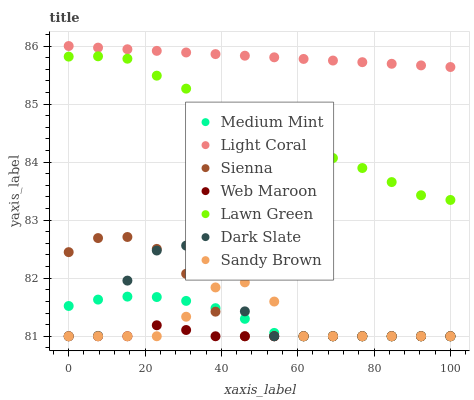Does Web Maroon have the minimum area under the curve?
Answer yes or no. Yes. Does Light Coral have the maximum area under the curve?
Answer yes or no. Yes. Does Lawn Green have the minimum area under the curve?
Answer yes or no. No. Does Lawn Green have the maximum area under the curve?
Answer yes or no. No. Is Light Coral the smoothest?
Answer yes or no. Yes. Is Dark Slate the roughest?
Answer yes or no. Yes. Is Lawn Green the smoothest?
Answer yes or no. No. Is Lawn Green the roughest?
Answer yes or no. No. Does Medium Mint have the lowest value?
Answer yes or no. Yes. Does Lawn Green have the lowest value?
Answer yes or no. No. Does Light Coral have the highest value?
Answer yes or no. Yes. Does Lawn Green have the highest value?
Answer yes or no. No. Is Sandy Brown less than Light Coral?
Answer yes or no. Yes. Is Lawn Green greater than Sandy Brown?
Answer yes or no. Yes. Does Medium Mint intersect Web Maroon?
Answer yes or no. Yes. Is Medium Mint less than Web Maroon?
Answer yes or no. No. Is Medium Mint greater than Web Maroon?
Answer yes or no. No. Does Sandy Brown intersect Light Coral?
Answer yes or no. No. 